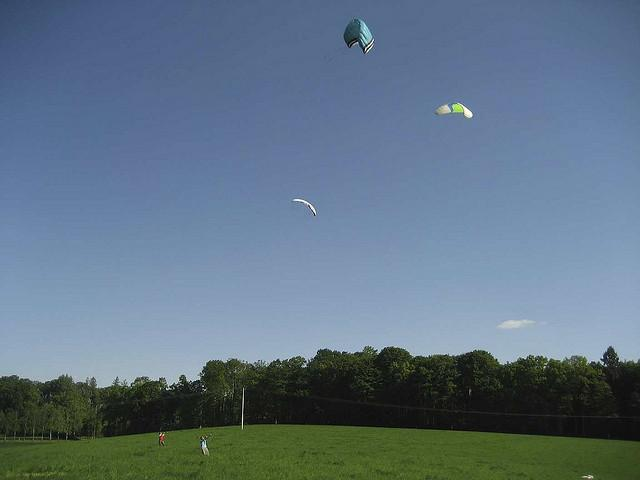The flying objects are made of what material?

Choices:
A) polyester
B) copper
C) aluminum
D) paper polyester 